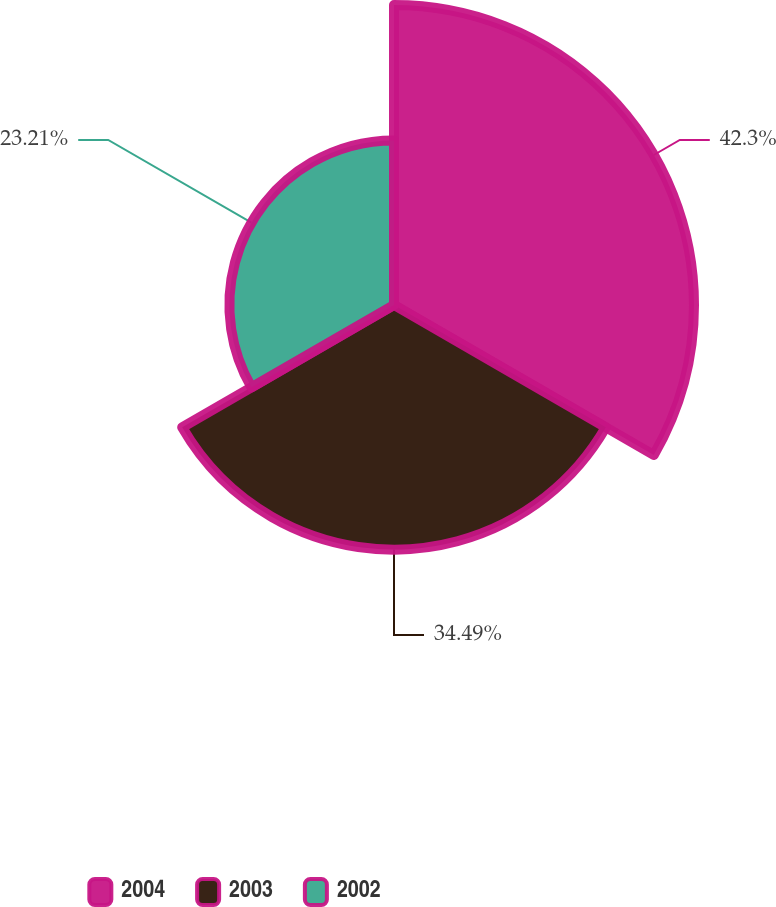Convert chart. <chart><loc_0><loc_0><loc_500><loc_500><pie_chart><fcel>2004<fcel>2003<fcel>2002<nl><fcel>42.3%<fcel>34.49%<fcel>23.21%<nl></chart> 